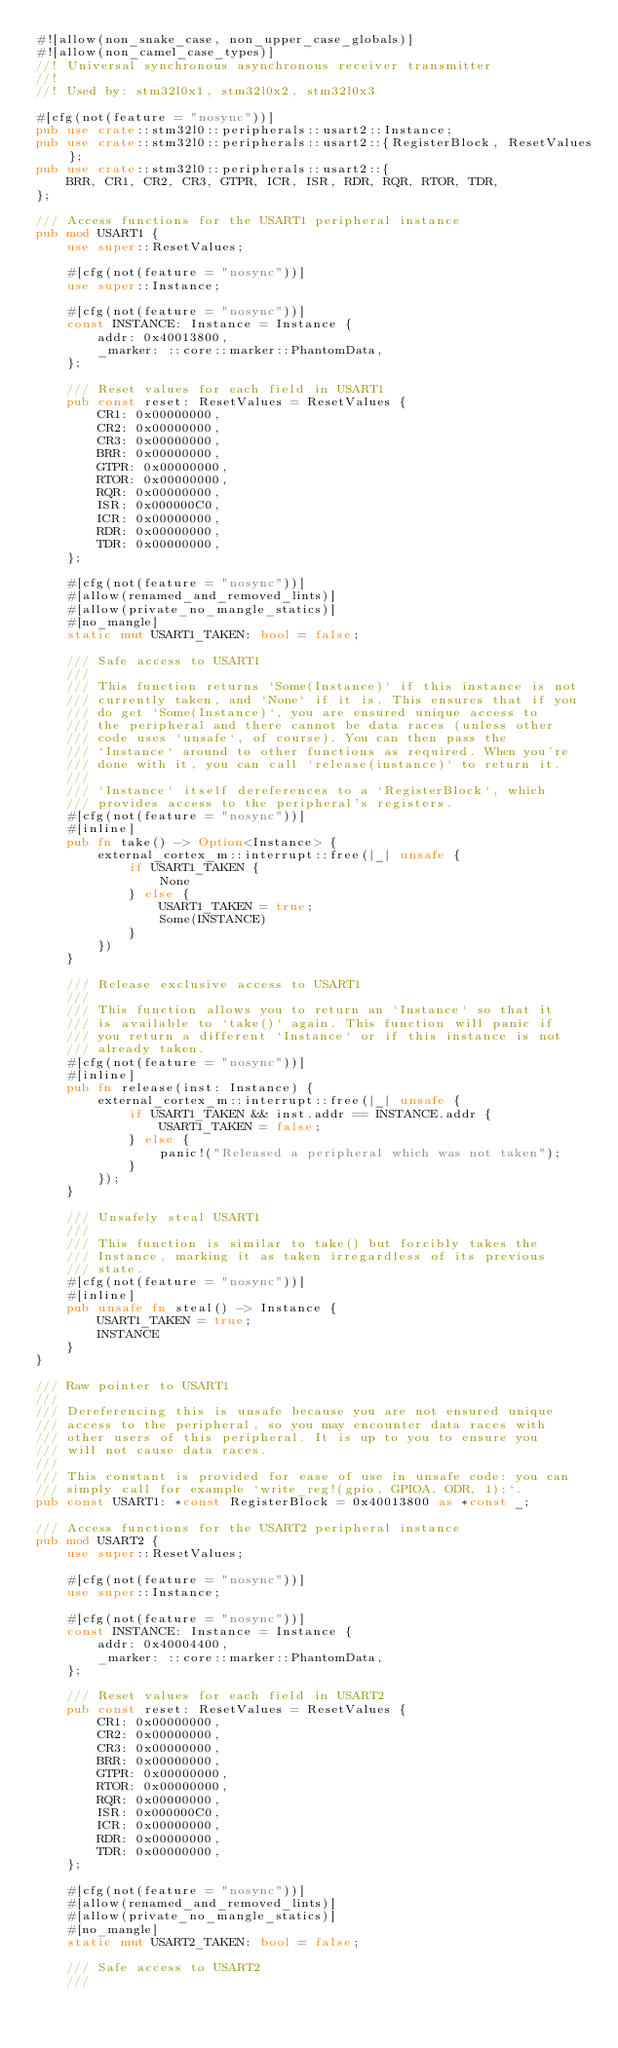Convert code to text. <code><loc_0><loc_0><loc_500><loc_500><_Rust_>#![allow(non_snake_case, non_upper_case_globals)]
#![allow(non_camel_case_types)]
//! Universal synchronous asynchronous receiver transmitter
//!
//! Used by: stm32l0x1, stm32l0x2, stm32l0x3

#[cfg(not(feature = "nosync"))]
pub use crate::stm32l0::peripherals::usart2::Instance;
pub use crate::stm32l0::peripherals::usart2::{RegisterBlock, ResetValues};
pub use crate::stm32l0::peripherals::usart2::{
    BRR, CR1, CR2, CR3, GTPR, ICR, ISR, RDR, RQR, RTOR, TDR,
};

/// Access functions for the USART1 peripheral instance
pub mod USART1 {
    use super::ResetValues;

    #[cfg(not(feature = "nosync"))]
    use super::Instance;

    #[cfg(not(feature = "nosync"))]
    const INSTANCE: Instance = Instance {
        addr: 0x40013800,
        _marker: ::core::marker::PhantomData,
    };

    /// Reset values for each field in USART1
    pub const reset: ResetValues = ResetValues {
        CR1: 0x00000000,
        CR2: 0x00000000,
        CR3: 0x00000000,
        BRR: 0x00000000,
        GTPR: 0x00000000,
        RTOR: 0x00000000,
        RQR: 0x00000000,
        ISR: 0x000000C0,
        ICR: 0x00000000,
        RDR: 0x00000000,
        TDR: 0x00000000,
    };

    #[cfg(not(feature = "nosync"))]
    #[allow(renamed_and_removed_lints)]
    #[allow(private_no_mangle_statics)]
    #[no_mangle]
    static mut USART1_TAKEN: bool = false;

    /// Safe access to USART1
    ///
    /// This function returns `Some(Instance)` if this instance is not
    /// currently taken, and `None` if it is. This ensures that if you
    /// do get `Some(Instance)`, you are ensured unique access to
    /// the peripheral and there cannot be data races (unless other
    /// code uses `unsafe`, of course). You can then pass the
    /// `Instance` around to other functions as required. When you're
    /// done with it, you can call `release(instance)` to return it.
    ///
    /// `Instance` itself dereferences to a `RegisterBlock`, which
    /// provides access to the peripheral's registers.
    #[cfg(not(feature = "nosync"))]
    #[inline]
    pub fn take() -> Option<Instance> {
        external_cortex_m::interrupt::free(|_| unsafe {
            if USART1_TAKEN {
                None
            } else {
                USART1_TAKEN = true;
                Some(INSTANCE)
            }
        })
    }

    /// Release exclusive access to USART1
    ///
    /// This function allows you to return an `Instance` so that it
    /// is available to `take()` again. This function will panic if
    /// you return a different `Instance` or if this instance is not
    /// already taken.
    #[cfg(not(feature = "nosync"))]
    #[inline]
    pub fn release(inst: Instance) {
        external_cortex_m::interrupt::free(|_| unsafe {
            if USART1_TAKEN && inst.addr == INSTANCE.addr {
                USART1_TAKEN = false;
            } else {
                panic!("Released a peripheral which was not taken");
            }
        });
    }

    /// Unsafely steal USART1
    ///
    /// This function is similar to take() but forcibly takes the
    /// Instance, marking it as taken irregardless of its previous
    /// state.
    #[cfg(not(feature = "nosync"))]
    #[inline]
    pub unsafe fn steal() -> Instance {
        USART1_TAKEN = true;
        INSTANCE
    }
}

/// Raw pointer to USART1
///
/// Dereferencing this is unsafe because you are not ensured unique
/// access to the peripheral, so you may encounter data races with
/// other users of this peripheral. It is up to you to ensure you
/// will not cause data races.
///
/// This constant is provided for ease of use in unsafe code: you can
/// simply call for example `write_reg!(gpio, GPIOA, ODR, 1);`.
pub const USART1: *const RegisterBlock = 0x40013800 as *const _;

/// Access functions for the USART2 peripheral instance
pub mod USART2 {
    use super::ResetValues;

    #[cfg(not(feature = "nosync"))]
    use super::Instance;

    #[cfg(not(feature = "nosync"))]
    const INSTANCE: Instance = Instance {
        addr: 0x40004400,
        _marker: ::core::marker::PhantomData,
    };

    /// Reset values for each field in USART2
    pub const reset: ResetValues = ResetValues {
        CR1: 0x00000000,
        CR2: 0x00000000,
        CR3: 0x00000000,
        BRR: 0x00000000,
        GTPR: 0x00000000,
        RTOR: 0x00000000,
        RQR: 0x00000000,
        ISR: 0x000000C0,
        ICR: 0x00000000,
        RDR: 0x00000000,
        TDR: 0x00000000,
    };

    #[cfg(not(feature = "nosync"))]
    #[allow(renamed_and_removed_lints)]
    #[allow(private_no_mangle_statics)]
    #[no_mangle]
    static mut USART2_TAKEN: bool = false;

    /// Safe access to USART2
    ///</code> 